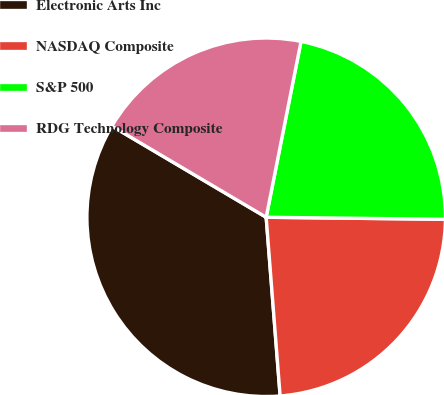Convert chart. <chart><loc_0><loc_0><loc_500><loc_500><pie_chart><fcel>Electronic Arts Inc<fcel>NASDAQ Composite<fcel>S&P 500<fcel>RDG Technology Composite<nl><fcel>34.74%<fcel>23.58%<fcel>22.07%<fcel>19.62%<nl></chart> 